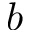Convert formula to latex. <formula><loc_0><loc_0><loc_500><loc_500>b</formula> 